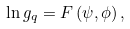<formula> <loc_0><loc_0><loc_500><loc_500>\ln g _ { q } = F \left ( \psi , \phi \right ) ,</formula> 